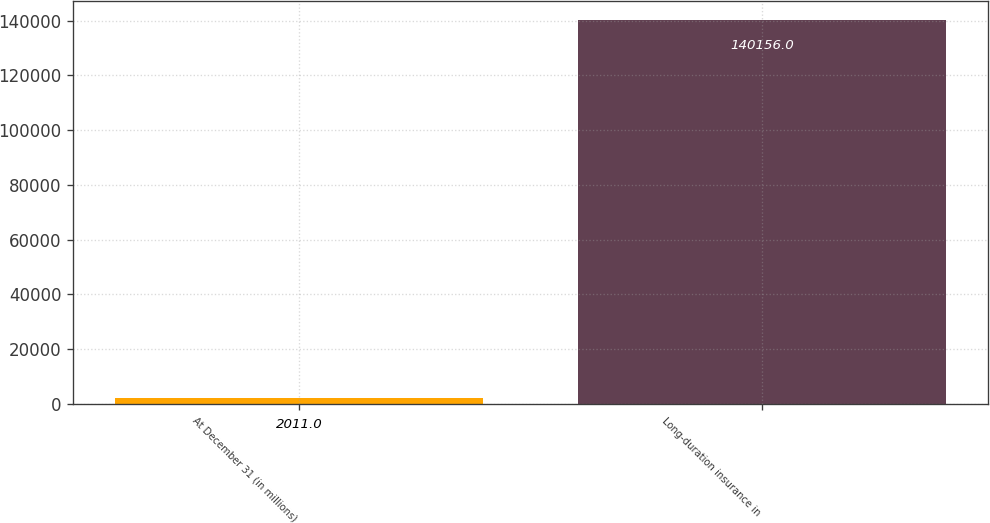<chart> <loc_0><loc_0><loc_500><loc_500><bar_chart><fcel>At December 31 (in millions)<fcel>Long-duration insurance in<nl><fcel>2011<fcel>140156<nl></chart> 